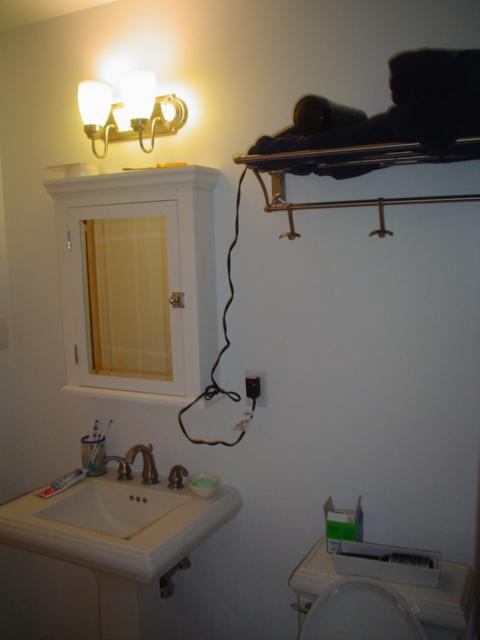Is something plugged in?
Answer briefly. Yes. Is the bathroom tidy?
Write a very short answer. Yes. Are the walls a solid color?
Be succinct. Yes. Is the cabinet black?
Quick response, please. No. What color is the wall?
Answer briefly. White. How many lights are on the bathroom wall?
Keep it brief. 2. What color are the towels?
Concise answer only. Black. What room is this photo of?
Answer briefly. Bathroom. How many tubes of toothpaste are on the sink?
Give a very brief answer. 1. What color is the shelf?
Be succinct. Brown. How many plugins are being used?
Short answer required. 1. Is this bathroom dirty?
Be succinct. No. Is this room a bathroom?
Concise answer only. Yes. Does this room belong to a male or female?
Be succinct. Male. Are there any windows in this room?
Keep it brief. No. What is in the clear bottle next to the faucet?
Give a very brief answer. Toothbrushes. What is coming out of the wall?
Answer briefly. Cord. What room is this?
Be succinct. Bathroom. Where is the women's purse?
Quick response, please. Shelf. How many lights are pictured?
Quick response, please. 2. Is the toilet seat cover up or down?
Quick response, please. Up. What color is the border on the mirror?
Give a very brief answer. White. Are there more than one color towel?
Give a very brief answer. No. What is on the wall?
Be succinct. Cabinet. Is the bathroom dirty?
Quick response, please. No. Where is the only light coming from?
Be succinct. Above sink. Is there a bathrobe hanging on the wall?
Give a very brief answer. No. Where is the cat?
Quick response, please. Nowhere. What color is the tape in the bathroom?
Quick response, please. Clear. Is there a hair dryer in the picture?
Give a very brief answer. Yes. What color is the soap?
Concise answer only. Green. What does the sink have?
Answer briefly. Faucet. Where was the picture taken of the bathroom?
Concise answer only. Doorway. 